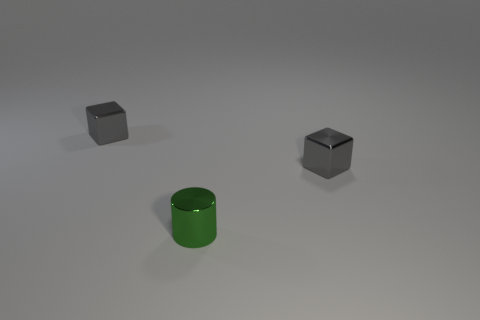What can you infer about the lighting in the scene? The scene appears to be softly lit from above. There are subtle shadows beneath the objects indicating the light source is not very intense. The lack of harsh shadows suggests that the lighting is diffused, perhaps by a wide light source or by ambient light in the environment. 